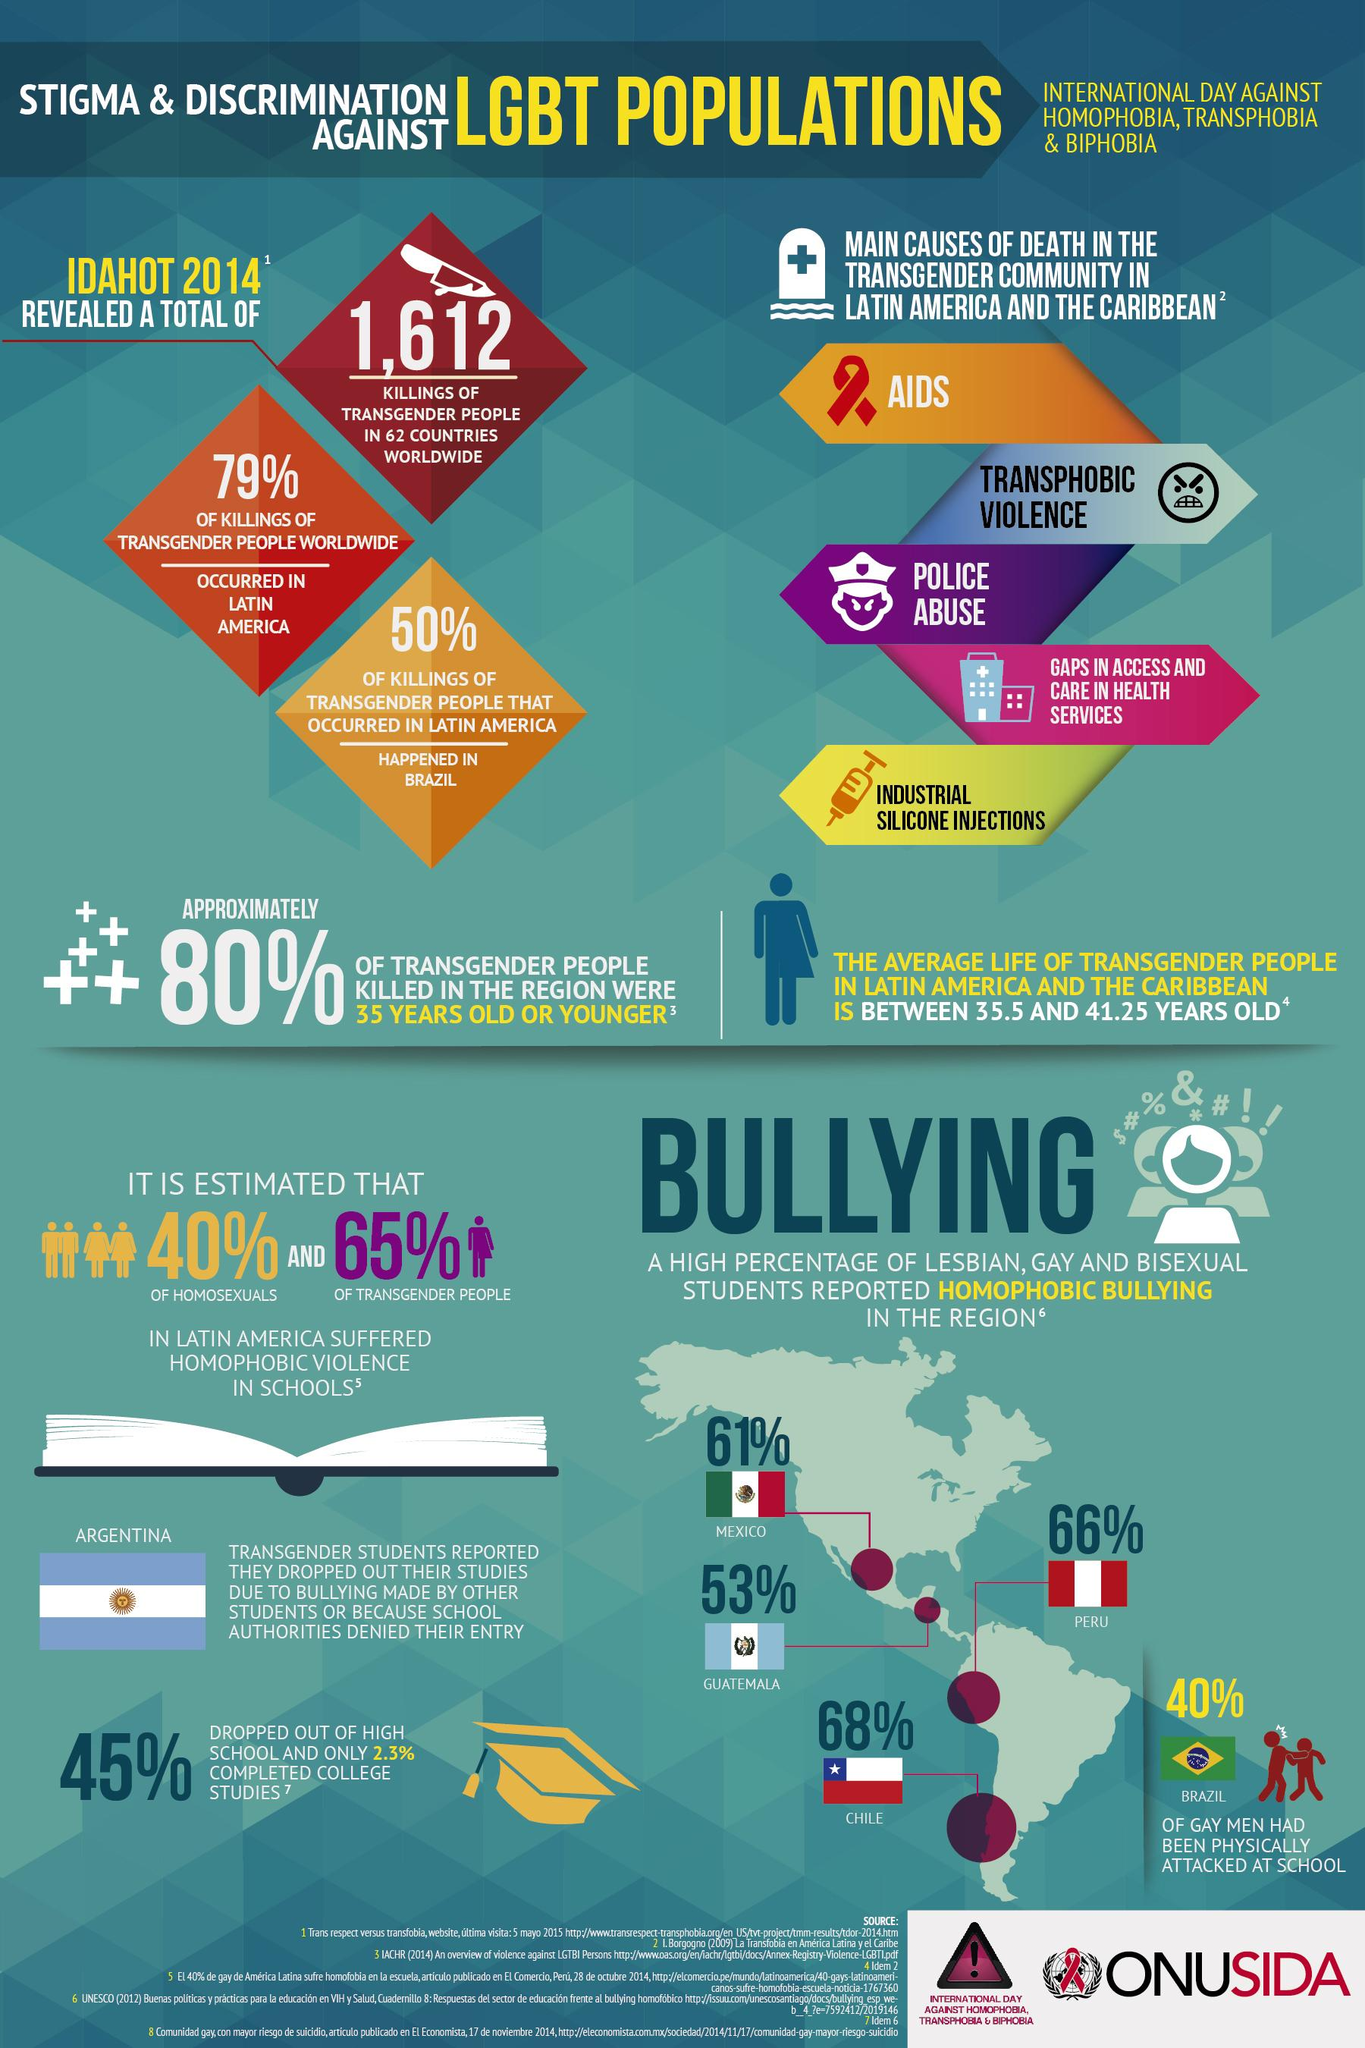Point out several critical features in this image. The most killings occurred in Brazil in Latin America. Police abuse is listed as the third leading cause of death among transgender individuals. In Guatemala, 53% of the reported cases of bullying were homophobic. According to the causes of death of transgender individuals, AIDS is the most prevalent cause of death. According to a report, 66% of all homophobic bullying incidents took place in Peru. 